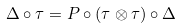Convert formula to latex. <formula><loc_0><loc_0><loc_500><loc_500>\Delta \circ \tau = P \circ ( \tau \otimes \tau ) \circ \Delta</formula> 